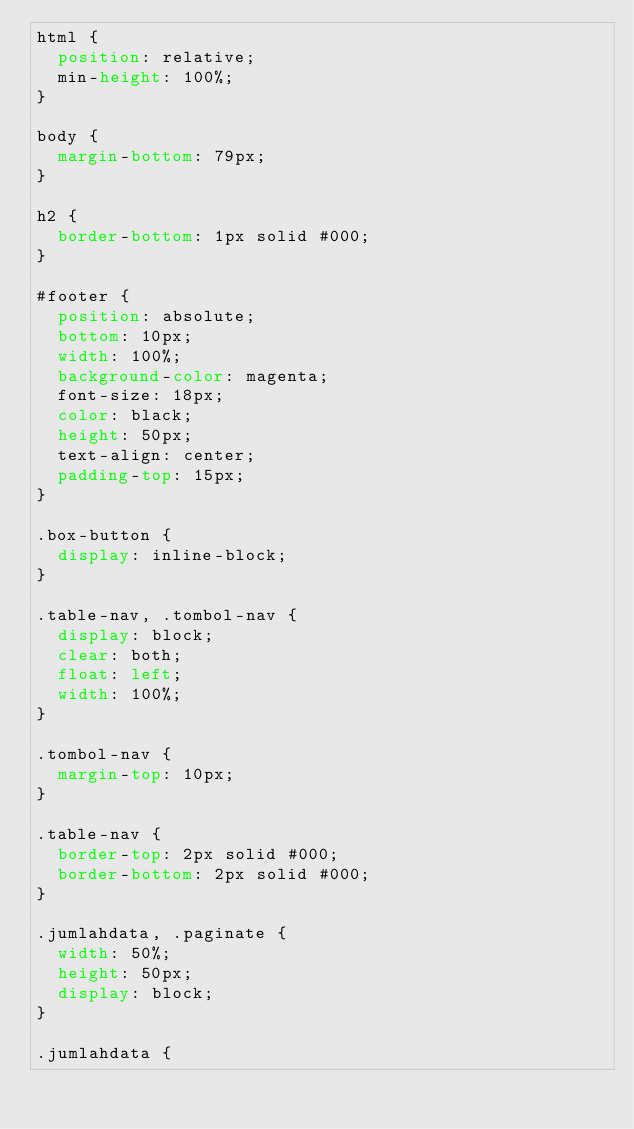<code> <loc_0><loc_0><loc_500><loc_500><_CSS_>html {
	position: relative;
	min-height: 100%;
}

body {
	margin-bottom: 79px;
}

h2 {
	border-bottom: 1px solid #000;
}

#footer {
	position: absolute;
	bottom: 10px;
	width: 100%;
	background-color: magenta;
	font-size: 18px;
	color: black;
	height: 50px;
	text-align: center;
	padding-top: 15px;
}

.box-button {
	display: inline-block;
}

.table-nav, .tombol-nav {
	display: block;
	clear: both;
	float: left;
	width: 100%;
}

.tombol-nav {
	margin-top: 10px;
}

.table-nav {
	border-top: 2px solid #000;
	border-bottom: 2px solid #000;
}

.jumlahdata, .paginate {
	width: 50%;
	height: 50px;
	display: block;
}

.jumlahdata {</code> 